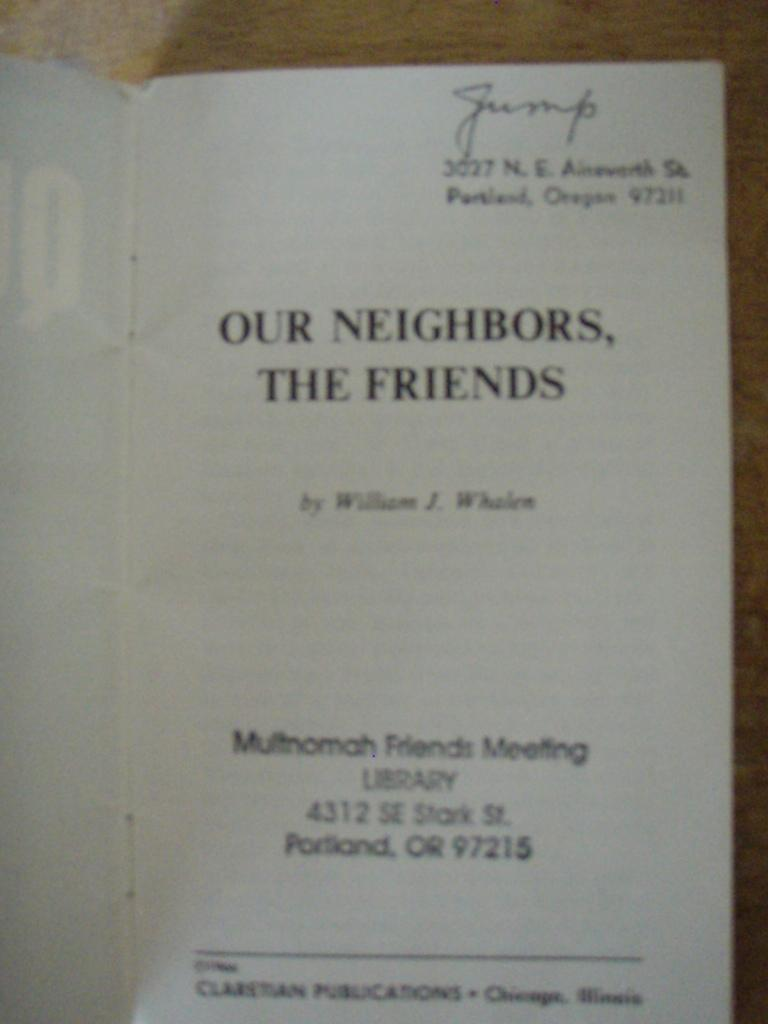<image>
Relay a brief, clear account of the picture shown. A book is open to its title page, which is Our Neighbors, The Friends. 